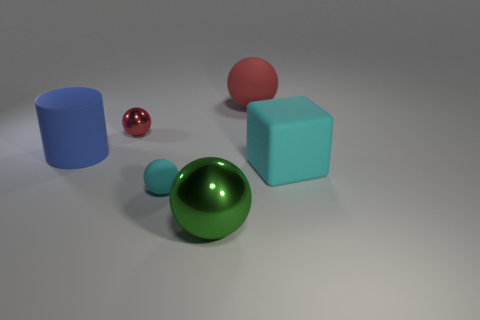What color is the thing that is the same material as the tiny red ball?
Your answer should be very brief. Green. Are there the same number of cyan matte cubes behind the cyan rubber cube and tiny cyan rubber things?
Ensure brevity in your answer.  No. What shape is the cyan object that is the same size as the red rubber sphere?
Your answer should be compact. Cube. How many other things are the same shape as the red matte thing?
Make the answer very short. 3. There is a rubber cylinder; is it the same size as the metal ball in front of the blue rubber thing?
Provide a short and direct response. Yes. How many things are balls that are to the left of the large green thing or green objects?
Make the answer very short. 3. What shape is the red object that is in front of the big red object?
Your answer should be compact. Sphere. Is the number of cyan rubber blocks that are on the left side of the blue matte thing the same as the number of balls that are behind the big green object?
Provide a succinct answer. No. The large thing that is both on the left side of the big red rubber object and behind the green sphere is what color?
Your answer should be very brief. Blue. There is a tiny ball behind the cylinder in front of the big red rubber thing; what is its material?
Give a very brief answer. Metal. 